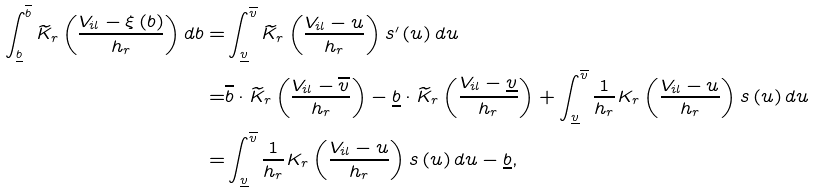Convert formula to latex. <formula><loc_0><loc_0><loc_500><loc_500>\int _ { \underline { b } } ^ { \overline { b } } \widetilde { K } _ { r } \left ( \frac { V _ { i l } - \xi \left ( b \right ) } { h _ { r } } \right ) d b = & \int _ { \underline { v } } ^ { \overline { v } } \widetilde { K } _ { r } \left ( \frac { V _ { i l } - u } { h _ { r } } \right ) s ^ { \prime } \left ( u \right ) d u \\ = & \overline { b } \cdot \widetilde { K } _ { r } \left ( \frac { V _ { i l } - \overline { v } } { h _ { r } } \right ) - \underline { b } \cdot \widetilde { K } _ { r } \left ( \frac { V _ { i l } - \underline { v } } { h _ { r } } \right ) + \int _ { \underline { v } } ^ { \overline { v } } \frac { 1 } { h _ { r } } K _ { r } \left ( \frac { V _ { i l } - u } { h _ { r } } \right ) s \left ( u \right ) d u \\ = & \int _ { \underline { v } } ^ { \overline { v } } \frac { 1 } { h _ { r } } K _ { r } \left ( \frac { V _ { i l } - u } { h _ { r } } \right ) s \left ( u \right ) d u - \underline { b } ,</formula> 